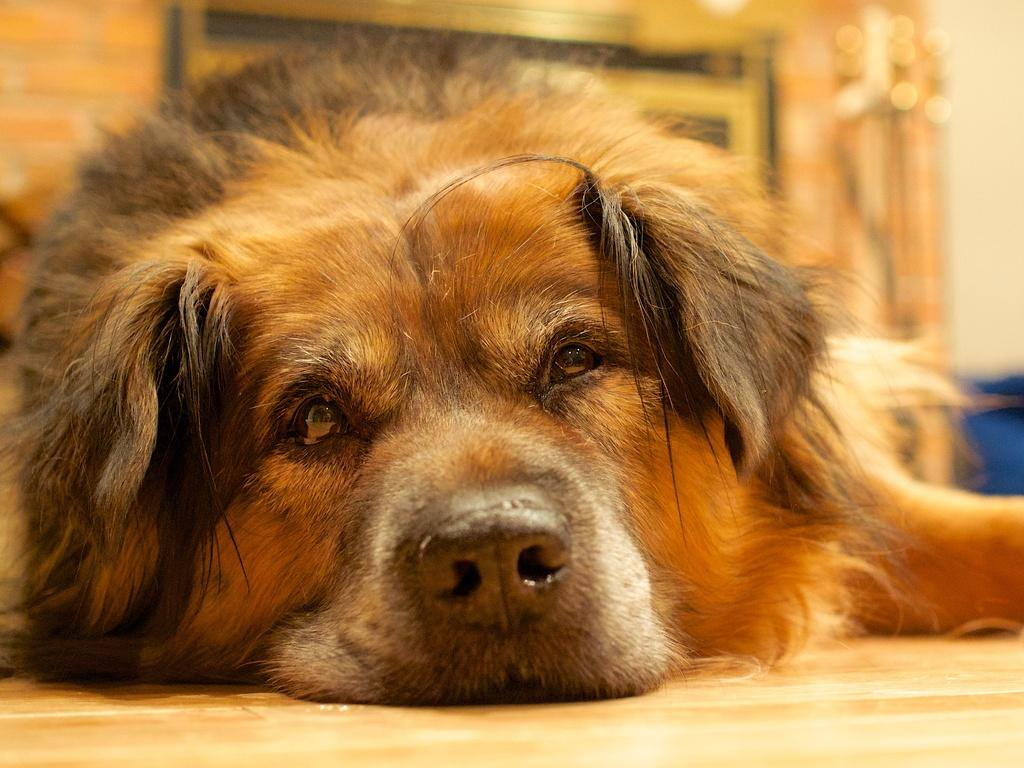What type of animal is present in the image? There is a dog in the image. What can be seen at the top of the image? There are objects at the top of the image. Can you describe the blue color object in the image? There is a blue color object on the right side of the image. What type of jeans is the dog wearing in the image? The dog is not wearing jeans in the image, as dogs do not wear clothing. 